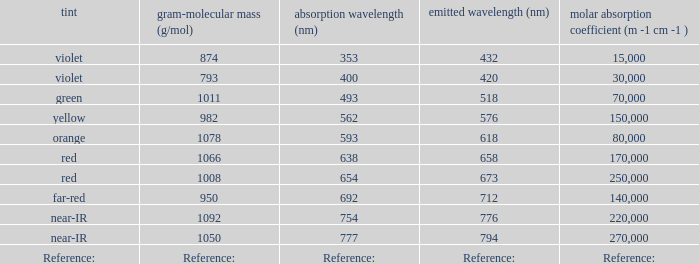Which Emission (in nanometers) that has a molar mass of 1078 g/mol? 618.0. Give me the full table as a dictionary. {'header': ['tint', 'gram-molecular mass (g/mol)', 'absorption wavelength (nm)', 'emitted wavelength (nm)', 'molar absorption coefficient (m -1 cm -1 )'], 'rows': [['violet', '874', '353', '432', '15,000'], ['violet', '793', '400', '420', '30,000'], ['green', '1011', '493', '518', '70,000'], ['yellow', '982', '562', '576', '150,000'], ['orange', '1078', '593', '618', '80,000'], ['red', '1066', '638', '658', '170,000'], ['red', '1008', '654', '673', '250,000'], ['far-red', '950', '692', '712', '140,000'], ['near-IR', '1092', '754', '776', '220,000'], ['near-IR', '1050', '777', '794', '270,000'], ['Reference:', 'Reference:', 'Reference:', 'Reference:', 'Reference:']]} 